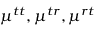<formula> <loc_0><loc_0><loc_500><loc_500>\mu ^ { t t } , \mu ^ { t r } , \mu ^ { r t }</formula> 